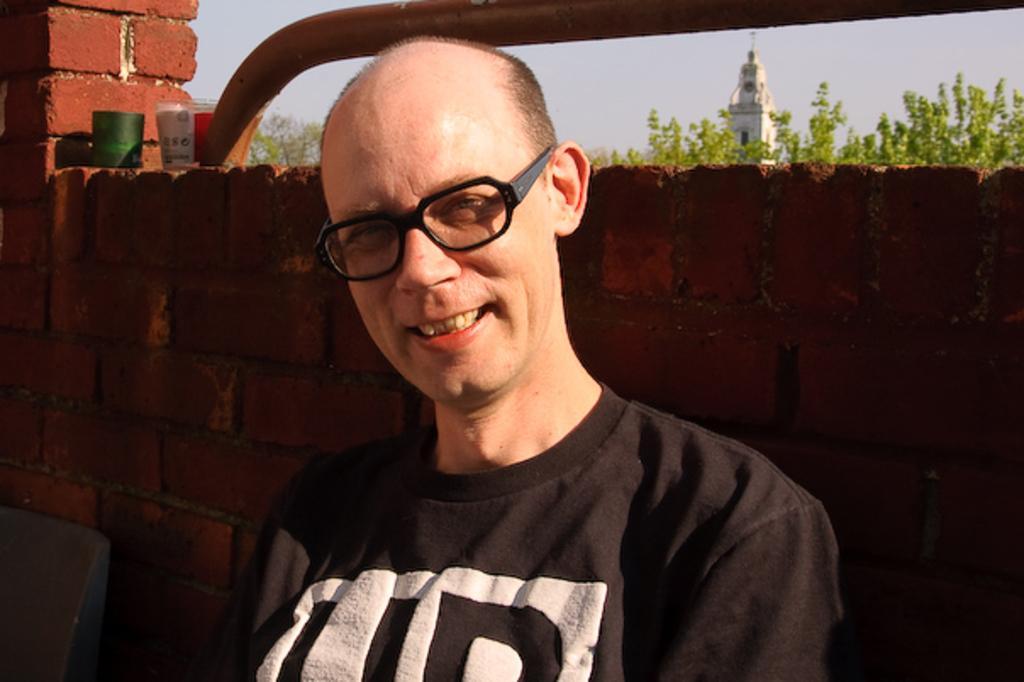In one or two sentences, can you explain what this image depicts? In the image we can see there is a person standing near the wall and the wall is made up red bricks. Behind there are trees and there is a building. 